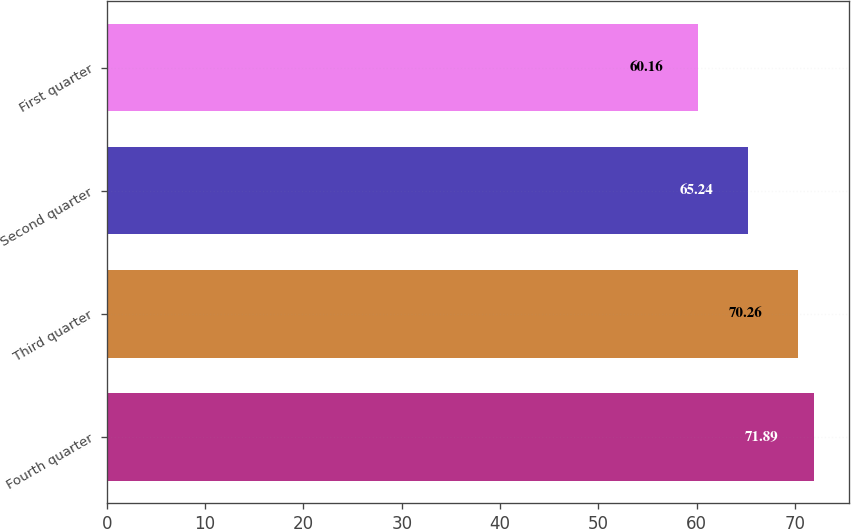<chart> <loc_0><loc_0><loc_500><loc_500><bar_chart><fcel>Fourth quarter<fcel>Third quarter<fcel>Second quarter<fcel>First quarter<nl><fcel>71.89<fcel>70.26<fcel>65.24<fcel>60.16<nl></chart> 